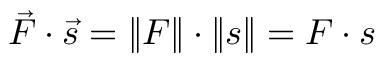<formula> <loc_0><loc_0><loc_500><loc_500>{ \vec { F } } \cdot { \vec { s } } = \| F \| \cdot \| s \| = F \cdot s</formula> 